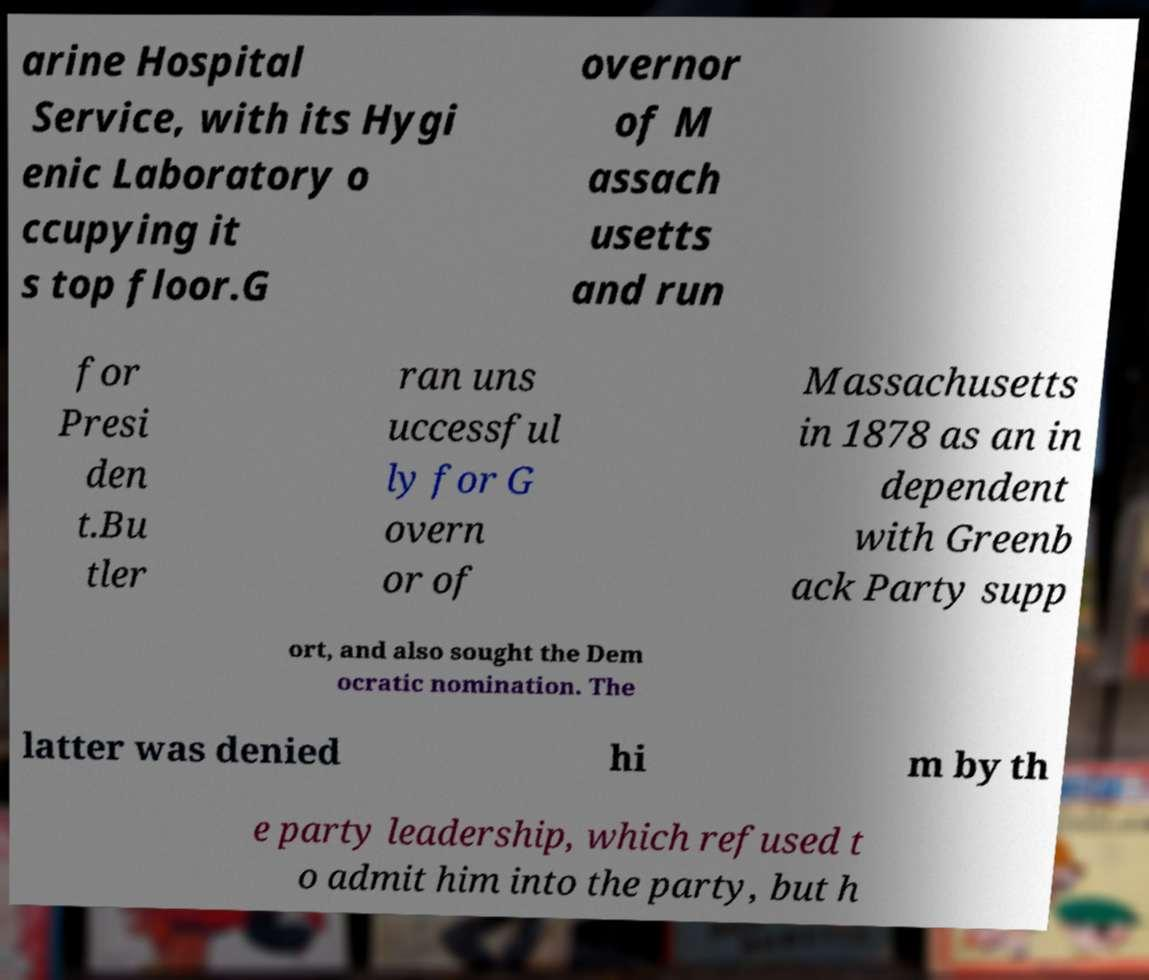Could you assist in decoding the text presented in this image and type it out clearly? arine Hospital Service, with its Hygi enic Laboratory o ccupying it s top floor.G overnor of M assach usetts and run for Presi den t.Bu tler ran uns uccessful ly for G overn or of Massachusetts in 1878 as an in dependent with Greenb ack Party supp ort, and also sought the Dem ocratic nomination. The latter was denied hi m by th e party leadership, which refused t o admit him into the party, but h 